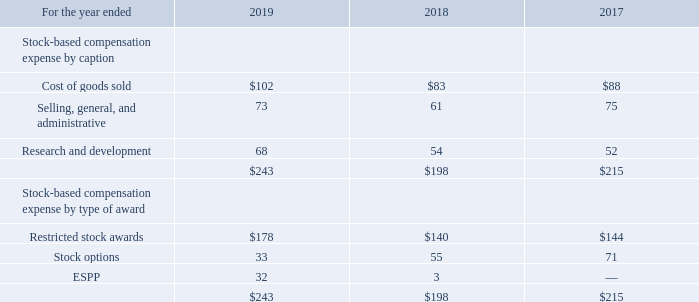Stock-based Compensation Expense
The income tax benefit related to share-based compensation was $66 million, $158 million and $97 million for 2019, 2018 and 2017, respectively. The income tax benefits related to share-based compensation for the periods presented prior to the second quarter of 2018 were offset by an increase in the U.S. valuation allowance. Stock-based compensation expense of $30 million and $19 million was capitalized and remained in inventory as of August 29, 2019 and August 30, 2018, respectively. As of August 29, 2019, $439 million of total unrecognized compensation costs for unvested awards, before the effect of any future forfeitures, was expected to be recognized through the fourth quarter of 2023, resulting in a weighted-average period of 1.3 years.
What is the percentage change in stock-based compensation expense from 2017 to 2018?
Answer scale should be: percent. ($198-$215)/$215 
Answer: -7.91. What is the difference between stock-based compensation expenses between 2018 and 2019?
Answer scale should be: million. $243-$198 
Answer: 45. What was the stock-based compensation expense of ESPP by type of reward in 2019?
Answer scale should be: million. 32. How much stock-based compensation expense was capitalized and remained in inventory as of August 29, 2019? $30 million. How much was the income tax benefit related to share-based compensation in 2018 and 2017 respectively? $158 million, $97 million. What is the proportion of income tax benefit related to share-based compensation over the total stock-based compensation expense in 2019? 66/243 
Answer: 0.27. 